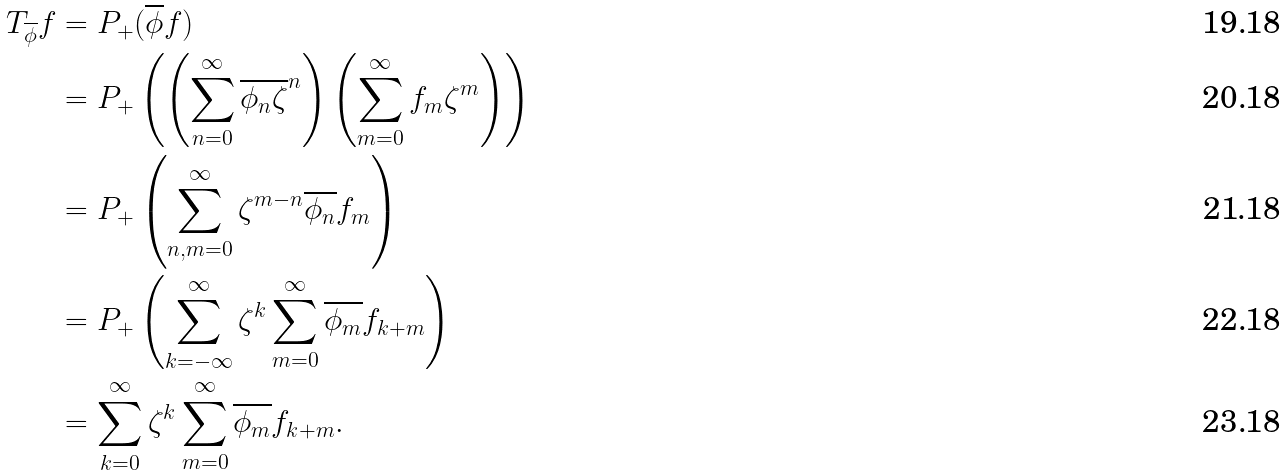<formula> <loc_0><loc_0><loc_500><loc_500>T _ { \overline { \phi } } f & = P _ { + } ( \overline { \phi } f ) \\ & = P _ { + } \left ( \left ( \sum _ { n = 0 } ^ { \infty } \overline { \phi _ { n } } \overline { \zeta } ^ { n } \right ) \left ( \sum _ { m = 0 } ^ { \infty } f _ { m } \zeta ^ { m } \right ) \right ) \\ & = P _ { + } \left ( \sum _ { n , m = 0 } ^ { \infty } \zeta ^ { m - n } \overline { \phi _ { n } } f _ { m } \right ) \\ & = P _ { + } \left ( \sum _ { k = - \infty } ^ { \infty } \zeta ^ { k } \sum _ { m = 0 } ^ { \infty } \overline { \phi _ { m } } f _ { k + m } \right ) \\ & = \sum _ { k = 0 } ^ { \infty } \zeta ^ { k } \sum _ { m = 0 } ^ { \infty } \overline { \phi _ { m } } f _ { k + m } .</formula> 